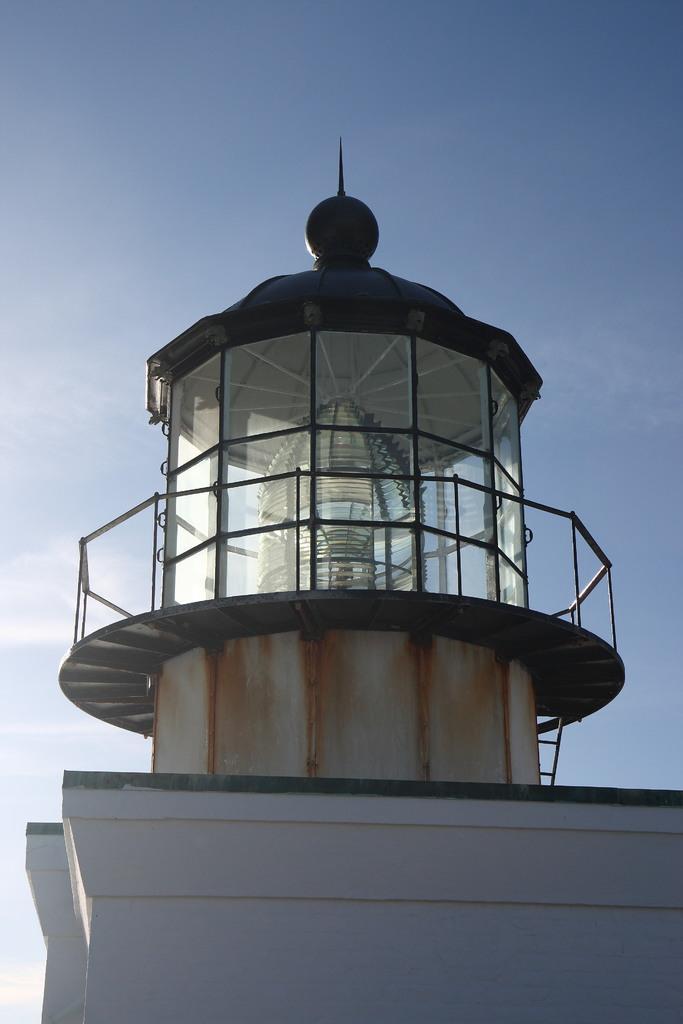In one or two sentences, can you explain what this image depicts? In this picture I can see there is a building, it has stairs and glass windows. The sky is clear and sunny. 